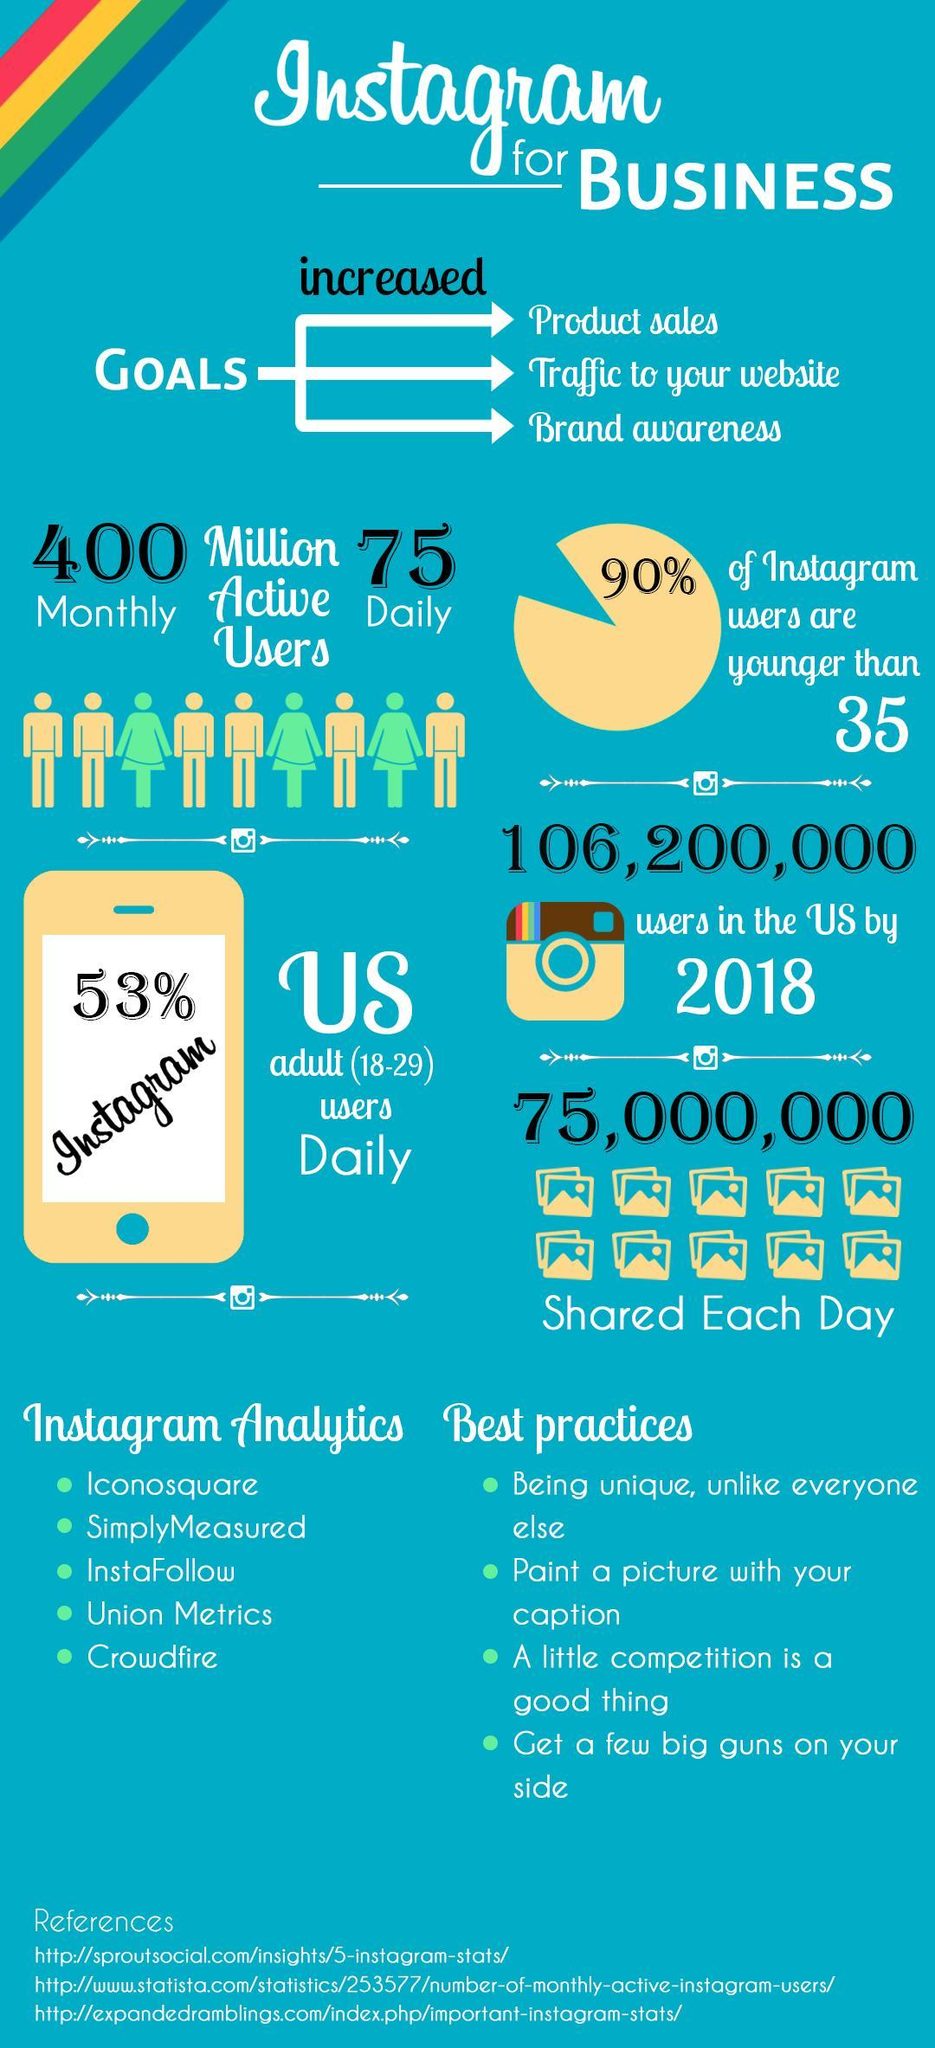What percentage of Instagram users are older than 35?
Answer the question with a short phrase. 10% 